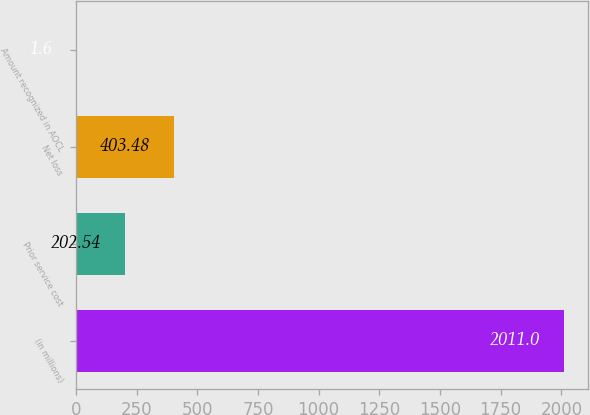Convert chart to OTSL. <chart><loc_0><loc_0><loc_500><loc_500><bar_chart><fcel>(in millions)<fcel>Prior service cost<fcel>Net loss<fcel>Amount recognized in AOCL<nl><fcel>2011<fcel>202.54<fcel>403.48<fcel>1.6<nl></chart> 